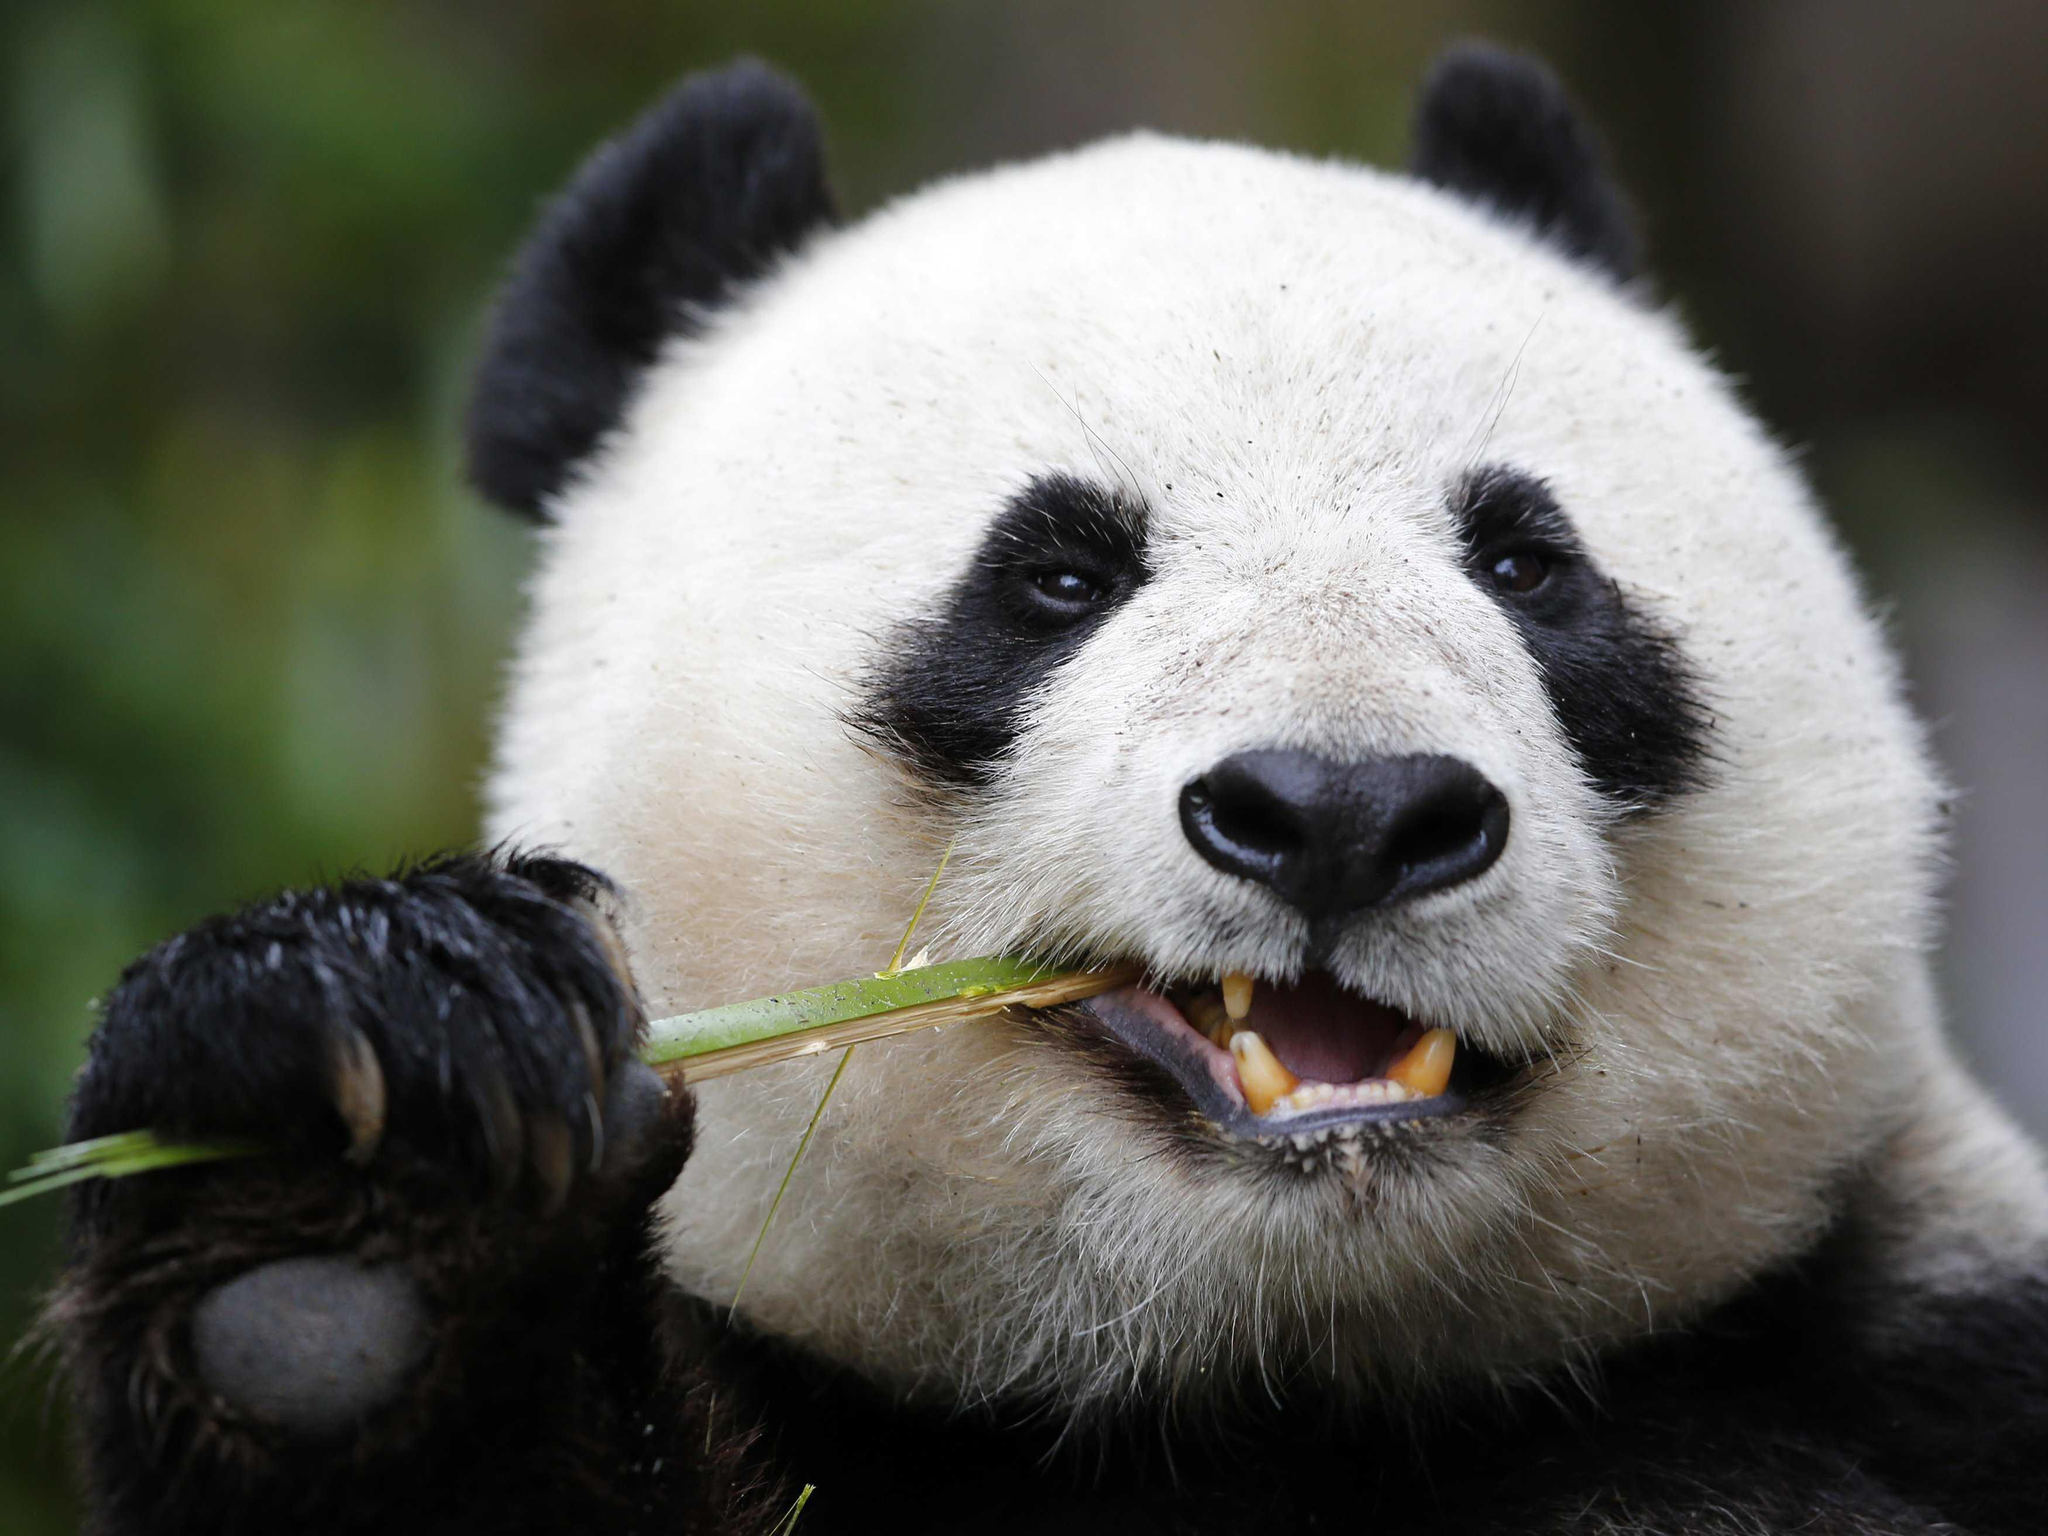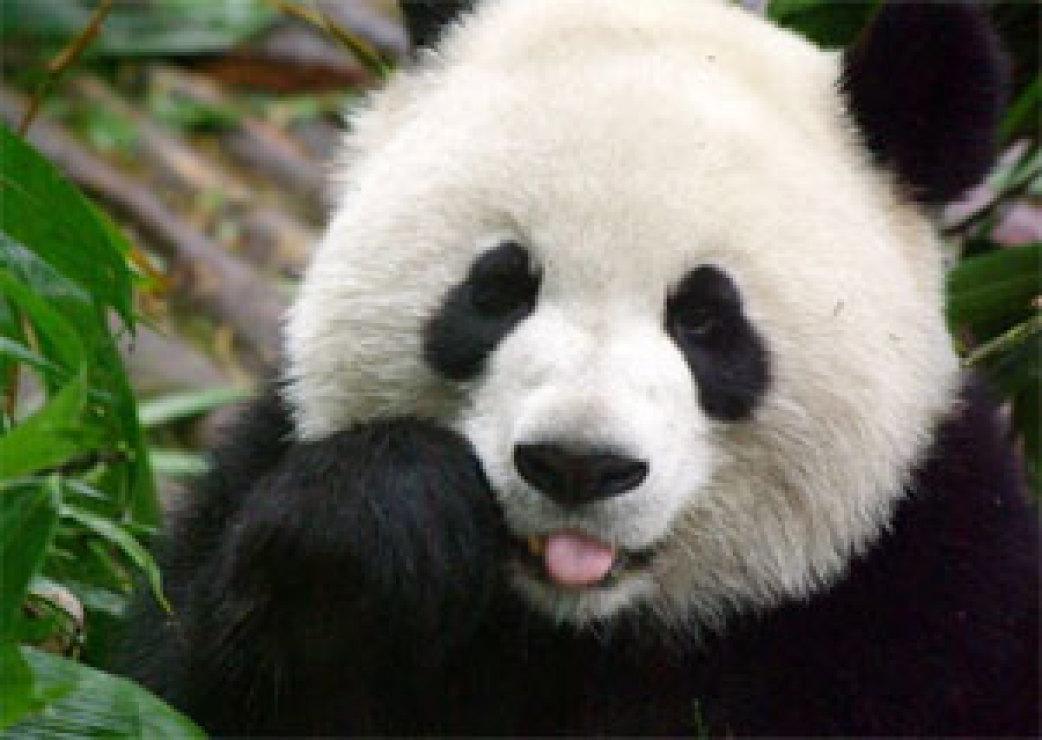The first image is the image on the left, the second image is the image on the right. Evaluate the accuracy of this statement regarding the images: "Two pandas are embracing each other.". Is it true? Answer yes or no. No. The first image is the image on the left, the second image is the image on the right. For the images shown, is this caption "An image shows a panda chewing on a green stalk." true? Answer yes or no. Yes. 